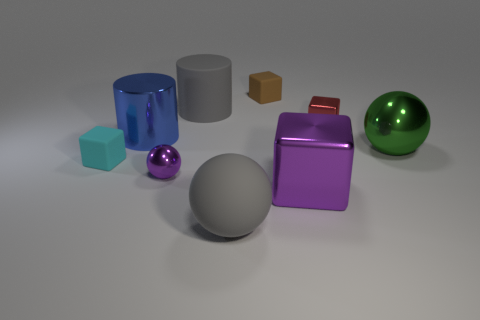Add 1 small red blocks. How many objects exist? 10 Subtract all big matte spheres. How many spheres are left? 2 Subtract all spheres. How many objects are left? 6 Subtract 3 balls. How many balls are left? 0 Subtract all red cubes. How many cubes are left? 3 Add 6 rubber balls. How many rubber balls are left? 7 Add 1 tiny red shiny cylinders. How many tiny red shiny cylinders exist? 1 Subtract 0 yellow cubes. How many objects are left? 9 Subtract all green balls. Subtract all purple cubes. How many balls are left? 2 Subtract all small shiny blocks. Subtract all gray objects. How many objects are left? 6 